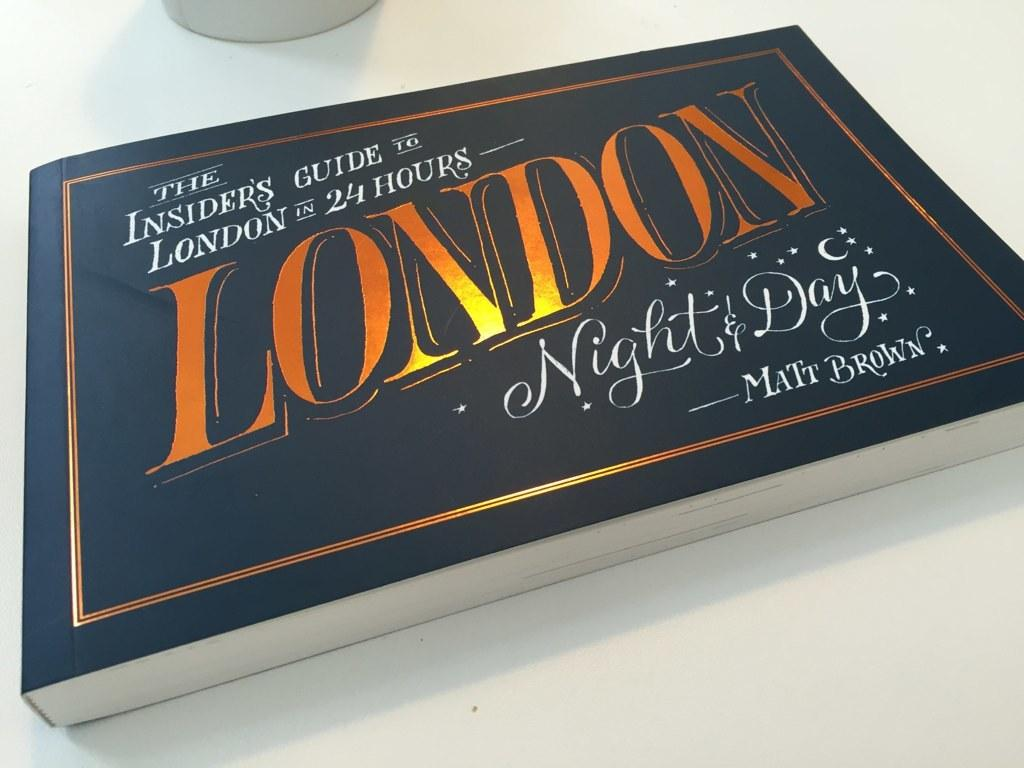Provide a one-sentence caption for the provided image. A book by Matt Brown that contains ideas on what to do with a day and night in London. 